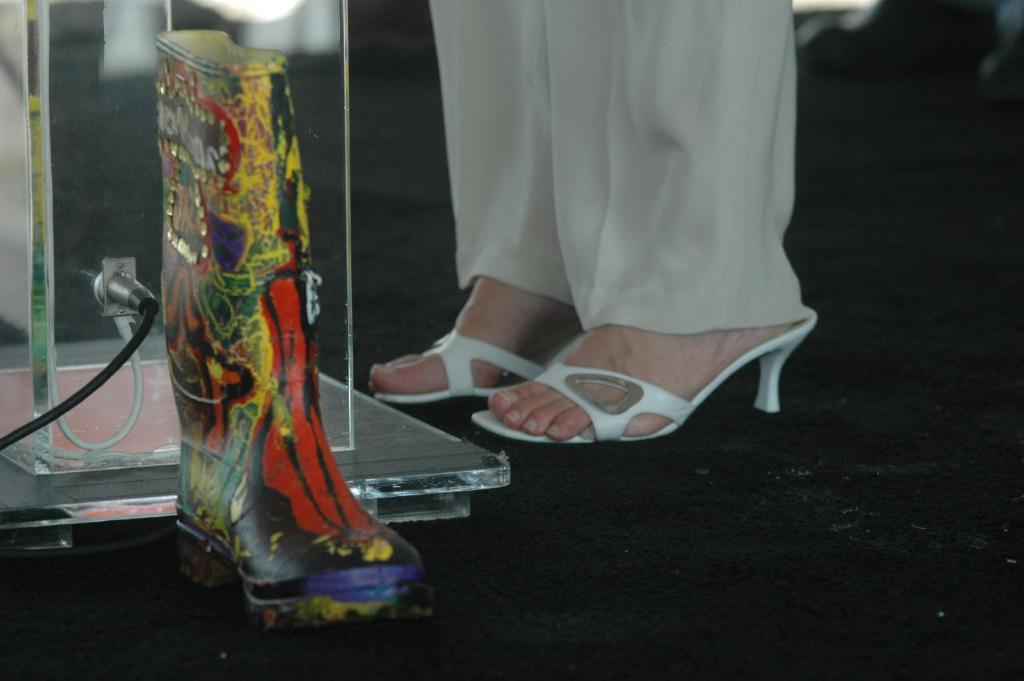What part of a person can be seen in the image? There are legs of a person visible in the image. What type of footwear is the person wearing? The person is wearing white color sandals. What type of clothing is the person wearing on their legs? The person is wearing white pants. What can be seen in the background of the image? There are wires and glasses visible in the background of the image. What type of pie is the farmer holding in the image? There is no farmer or pie present in the image. Can you recite the verse that is written on the glasses in the image? There is no verse written on the glasses in the image; they are simply visible in the background. 